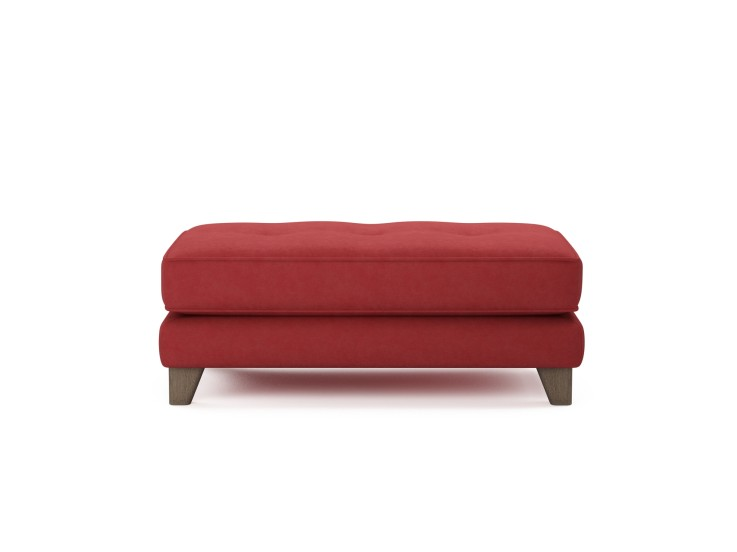Can this ottoman be used in a commercial setting? What considerations should be taken into account? This ottoman could indeed be utilized in a commercial setting like a boutique hotel lobby or a contemporary business lounge. Key considerations would include its durability and material quality to ensure it withstands frequent use. Additionally, its color could be used strategically to complement or contrast with the existing decor, providing a welcoming and stylish seating option. 